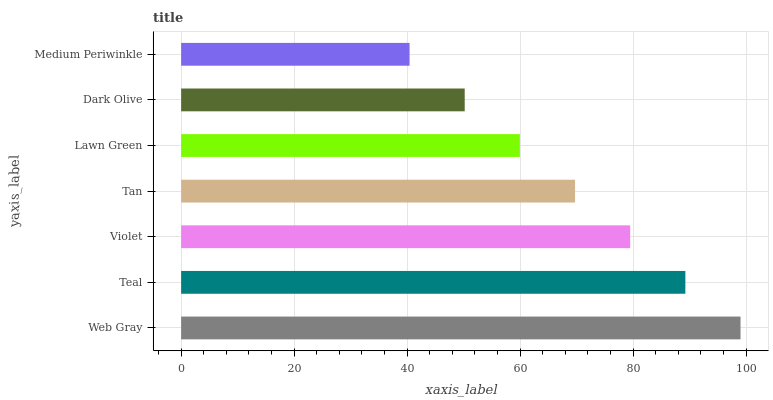Is Medium Periwinkle the minimum?
Answer yes or no. Yes. Is Web Gray the maximum?
Answer yes or no. Yes. Is Teal the minimum?
Answer yes or no. No. Is Teal the maximum?
Answer yes or no. No. Is Web Gray greater than Teal?
Answer yes or no. Yes. Is Teal less than Web Gray?
Answer yes or no. Yes. Is Teal greater than Web Gray?
Answer yes or no. No. Is Web Gray less than Teal?
Answer yes or no. No. Is Tan the high median?
Answer yes or no. Yes. Is Tan the low median?
Answer yes or no. Yes. Is Violet the high median?
Answer yes or no. No. Is Web Gray the low median?
Answer yes or no. No. 